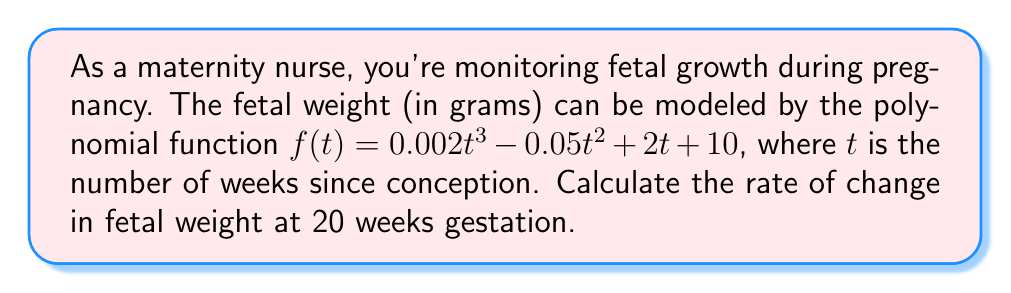What is the answer to this math problem? To find the rate of change in fetal weight at 20 weeks gestation, we need to calculate the derivative of the given function and evaluate it at $t = 20$.

1. The given polynomial function is:
   $f(t) = 0.002t^3 - 0.05t^2 + 2t + 10$

2. To find the rate of change, we need to find $f'(t)$:
   $f'(t) = \frac{d}{dt}(0.002t^3 - 0.05t^2 + 2t + 10)$
   $f'(t) = 0.006t^2 - 0.1t + 2$

3. Now, we evaluate $f'(t)$ at $t = 20$:
   $f'(20) = 0.006(20)^2 - 0.1(20) + 2$
   $f'(20) = 0.006(400) - 2 + 2$
   $f'(20) = 2.4 - 2 + 2$
   $f'(20) = 2.4$

The rate of change at 20 weeks gestation is 2.4 grams per week.
Answer: 2.4 grams per week 